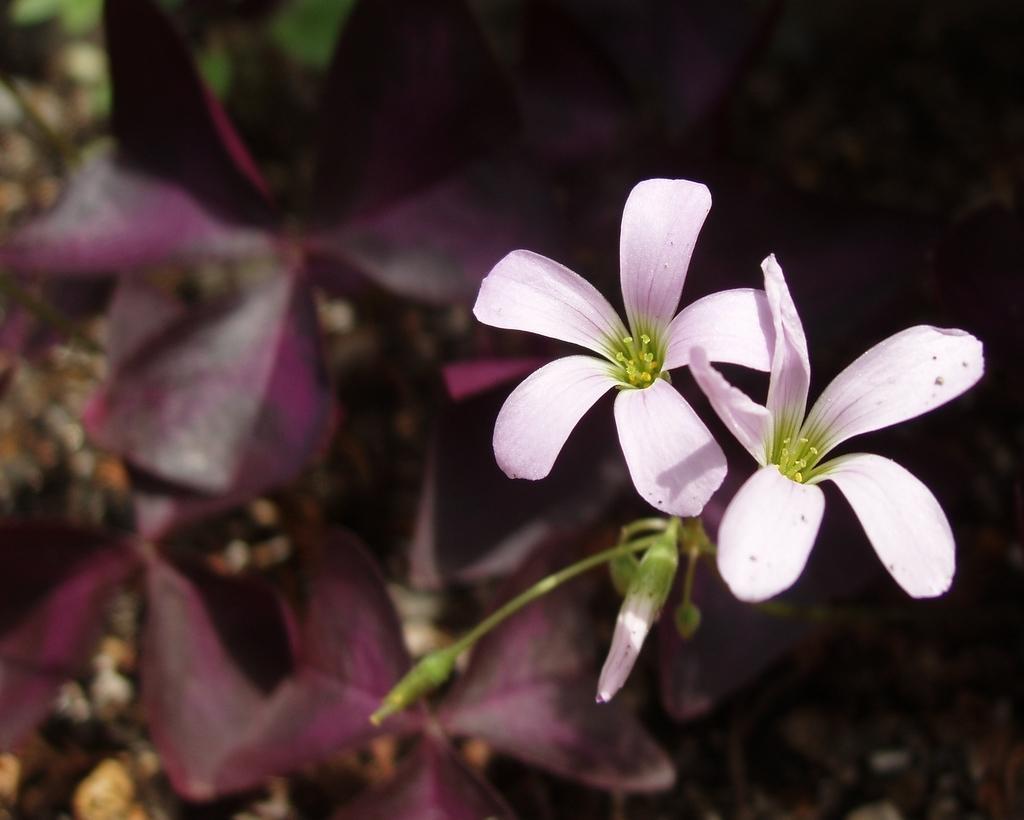How would you summarize this image in a sentence or two? In this image we can see the two flowers. The background of the image is slightly blurred, where we can see plants and stones on the ground. 